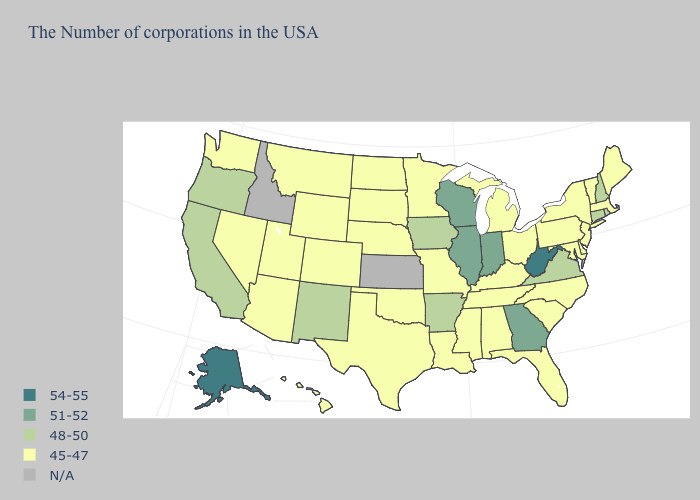What is the lowest value in the USA?
Be succinct. 45-47. What is the value of Arkansas?
Concise answer only. 48-50. Among the states that border Rhode Island , which have the highest value?
Answer briefly. Connecticut. Among the states that border Minnesota , does North Dakota have the lowest value?
Keep it brief. Yes. Name the states that have a value in the range 45-47?
Answer briefly. Maine, Massachusetts, Vermont, New York, New Jersey, Delaware, Maryland, Pennsylvania, North Carolina, South Carolina, Ohio, Florida, Michigan, Kentucky, Alabama, Tennessee, Mississippi, Louisiana, Missouri, Minnesota, Nebraska, Oklahoma, Texas, South Dakota, North Dakota, Wyoming, Colorado, Utah, Montana, Arizona, Nevada, Washington, Hawaii. Does Arkansas have the lowest value in the South?
Answer briefly. No. What is the highest value in the USA?
Answer briefly. 54-55. What is the value of Connecticut?
Be succinct. 48-50. Does New Hampshire have the lowest value in the USA?
Write a very short answer. No. Which states have the lowest value in the South?
Keep it brief. Delaware, Maryland, North Carolina, South Carolina, Florida, Kentucky, Alabama, Tennessee, Mississippi, Louisiana, Oklahoma, Texas. Among the states that border South Dakota , which have the highest value?
Short answer required. Iowa. What is the value of Arkansas?
Keep it brief. 48-50. Name the states that have a value in the range 48-50?
Keep it brief. Rhode Island, New Hampshire, Connecticut, Virginia, Arkansas, Iowa, New Mexico, California, Oregon. Does Connecticut have the lowest value in the Northeast?
Quick response, please. No. What is the lowest value in states that border Vermont?
Be succinct. 45-47. 